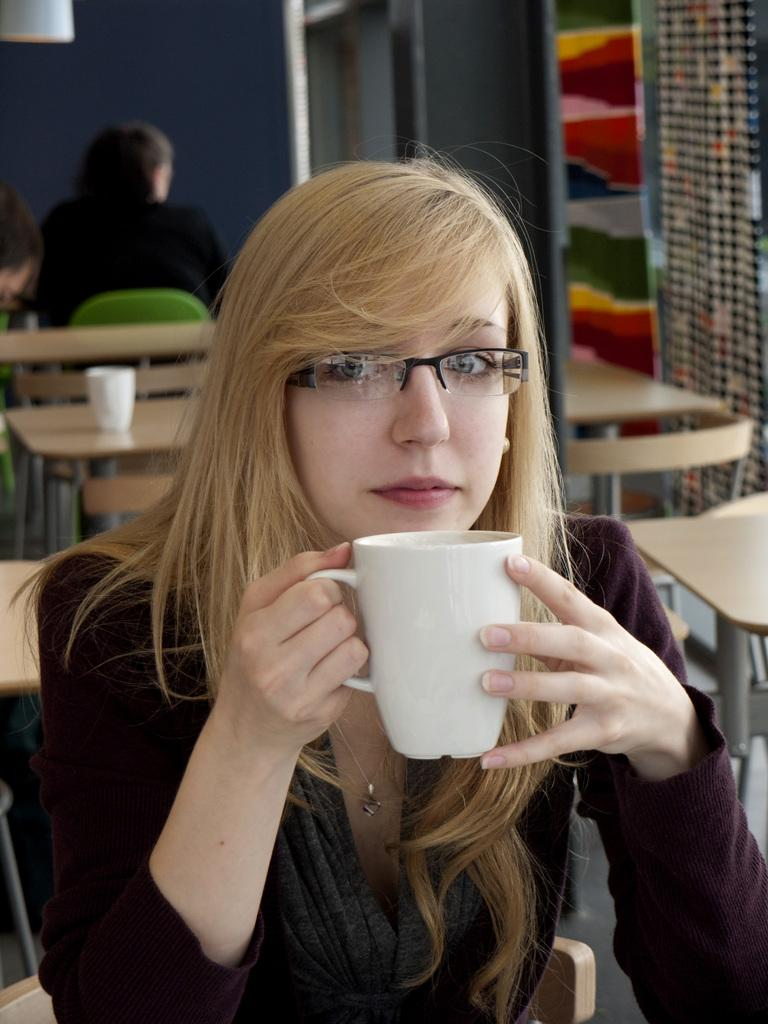What is the woman in the image doing? The woman is sitting on a chair in the image. What is the woman holding in the image? The woman is holding a cup. What can be seen in the background of the image? There are other tables and a wall visible in the background. Is there anyone else present in the image? Yes, there is a person sitting at one of the tables. What type of flavor can be tasted in the exchange between the woman and the person at the table? There is no exchange between the woman and the person at the table in the image, and therefore no flavor can be tasted. 